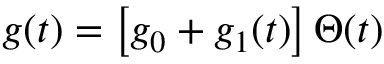Convert formula to latex. <formula><loc_0><loc_0><loc_500><loc_500>g ( t ) = \left [ g _ { 0 } + g _ { 1 } ( t ) \right ] \, \Theta ( t )</formula> 